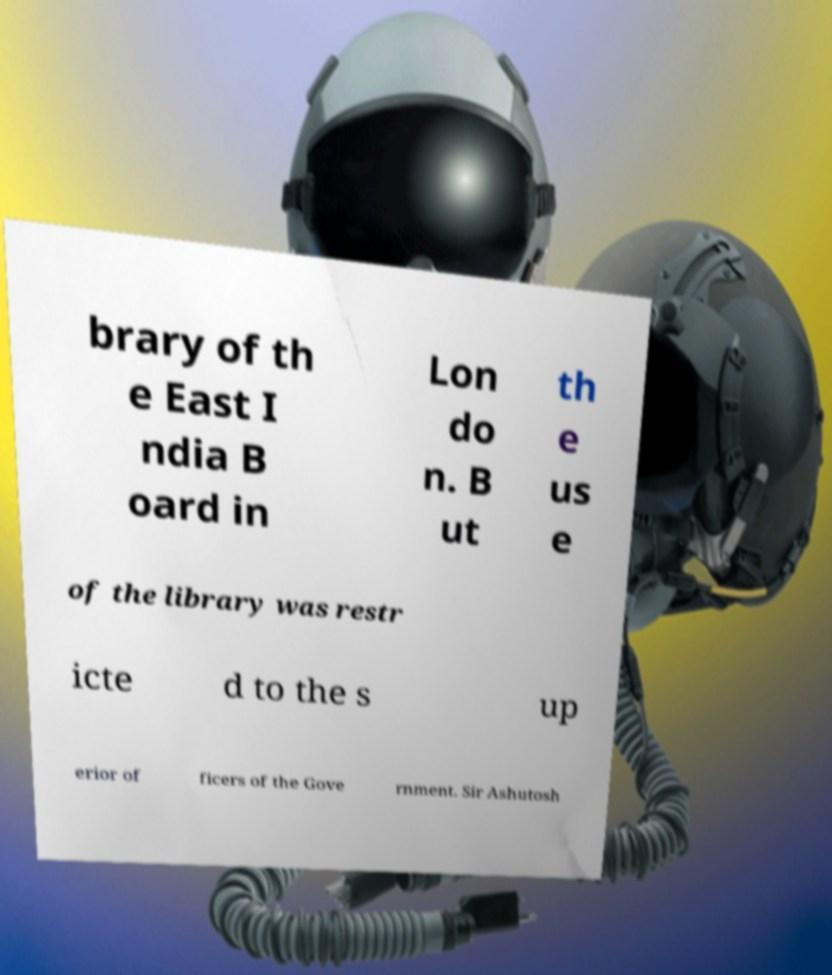Could you assist in decoding the text presented in this image and type it out clearly? brary of th e East I ndia B oard in Lon do n. B ut th e us e of the library was restr icte d to the s up erior of ficers of the Gove rnment. Sir Ashutosh 